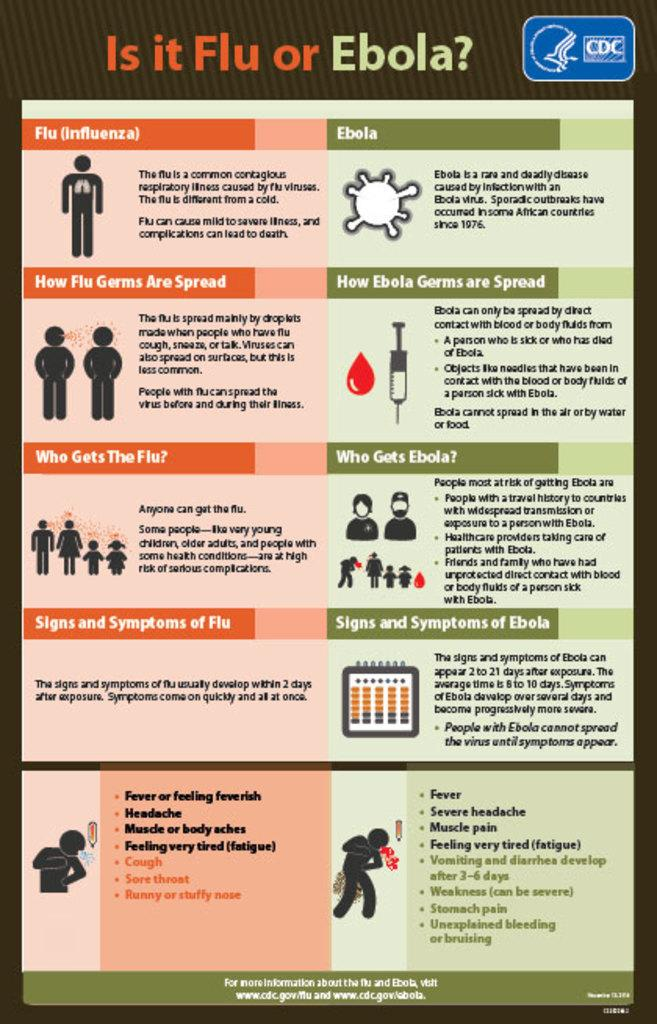<image>
Offer a succinct explanation of the picture presented. An Is it Flu or Ebola awareness health poster. 